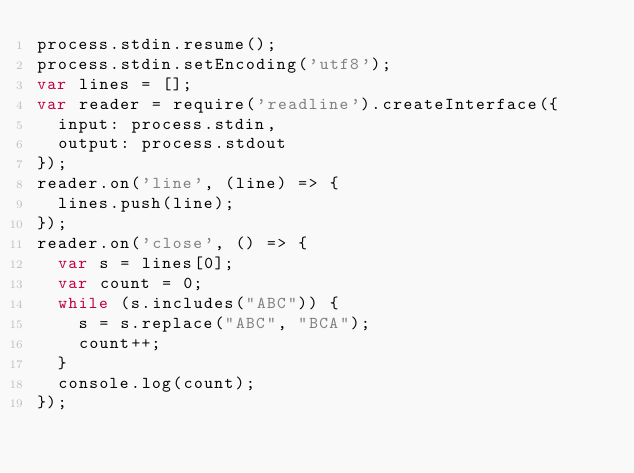<code> <loc_0><loc_0><loc_500><loc_500><_JavaScript_>process.stdin.resume();
process.stdin.setEncoding('utf8');
var lines = [];
var reader = require('readline').createInterface({
  input: process.stdin,
  output: process.stdout
});
reader.on('line', (line) => {
  lines.push(line);
});
reader.on('close', () => {
  var s = lines[0];
  var count = 0;
  while (s.includes("ABC")) {
  	s = s.replace("ABC", "BCA");
  	count++;
  }
  console.log(count);
});</code> 